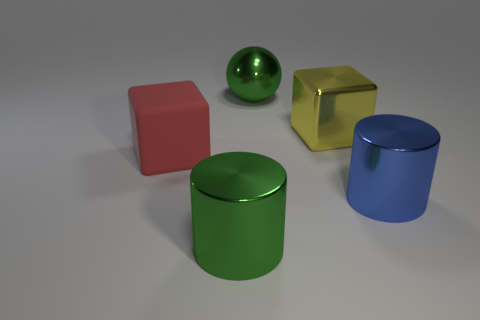The cylinder that is the same color as the metal sphere is what size?
Provide a short and direct response. Large. There is another thing that is the same shape as the yellow metal thing; what is it made of?
Provide a short and direct response. Rubber. Does the cylinder in front of the blue thing have the same color as the big matte thing?
Your answer should be compact. No. Does the large green sphere have the same material as the red thing that is behind the blue metal object?
Your answer should be very brief. No. What is the shape of the large green shiny object right of the large green metallic cylinder?
Provide a short and direct response. Sphere. How many other things are made of the same material as the yellow block?
Provide a short and direct response. 3. The green cylinder has what size?
Offer a very short reply. Large. What number of other things are the same color as the shiny ball?
Provide a short and direct response. 1. There is a large thing that is both to the left of the big blue shiny thing and in front of the large red thing; what color is it?
Provide a short and direct response. Green. How many large blocks are there?
Your response must be concise. 2. 